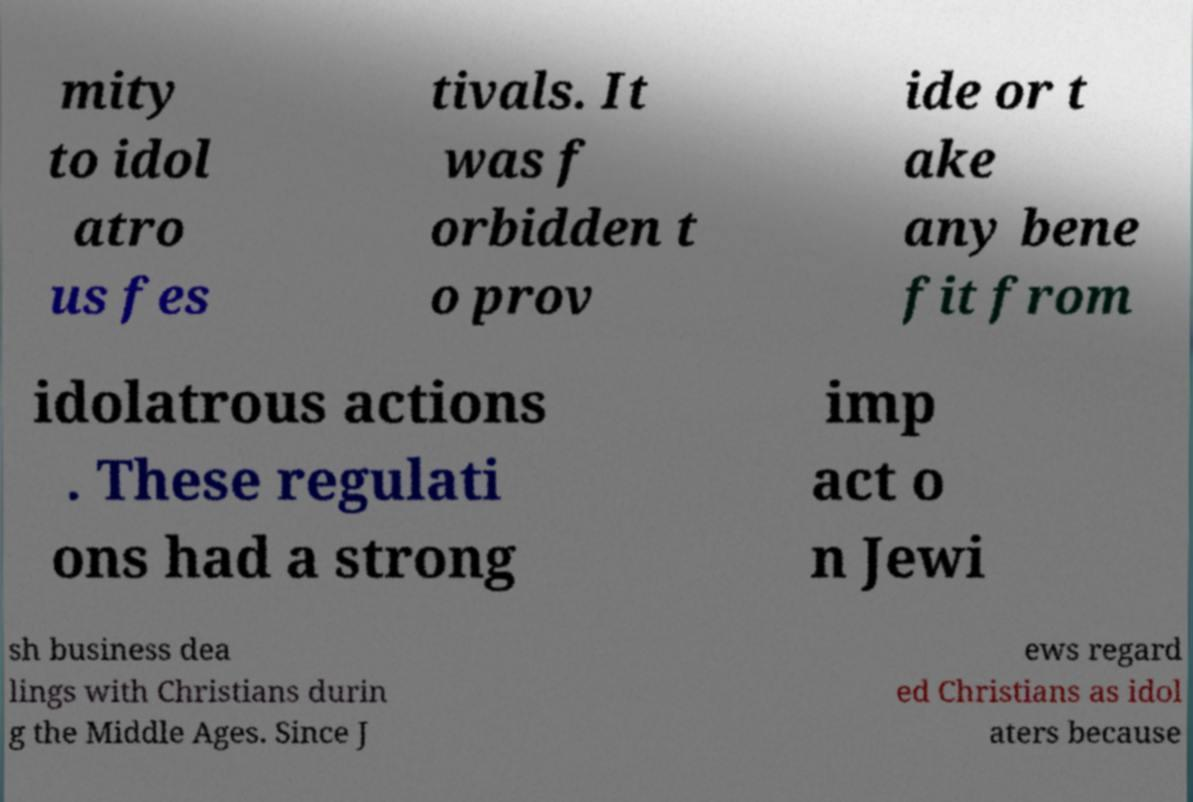Could you extract and type out the text from this image? mity to idol atro us fes tivals. It was f orbidden t o prov ide or t ake any bene fit from idolatrous actions . These regulati ons had a strong imp act o n Jewi sh business dea lings with Christians durin g the Middle Ages. Since J ews regard ed Christians as idol aters because 